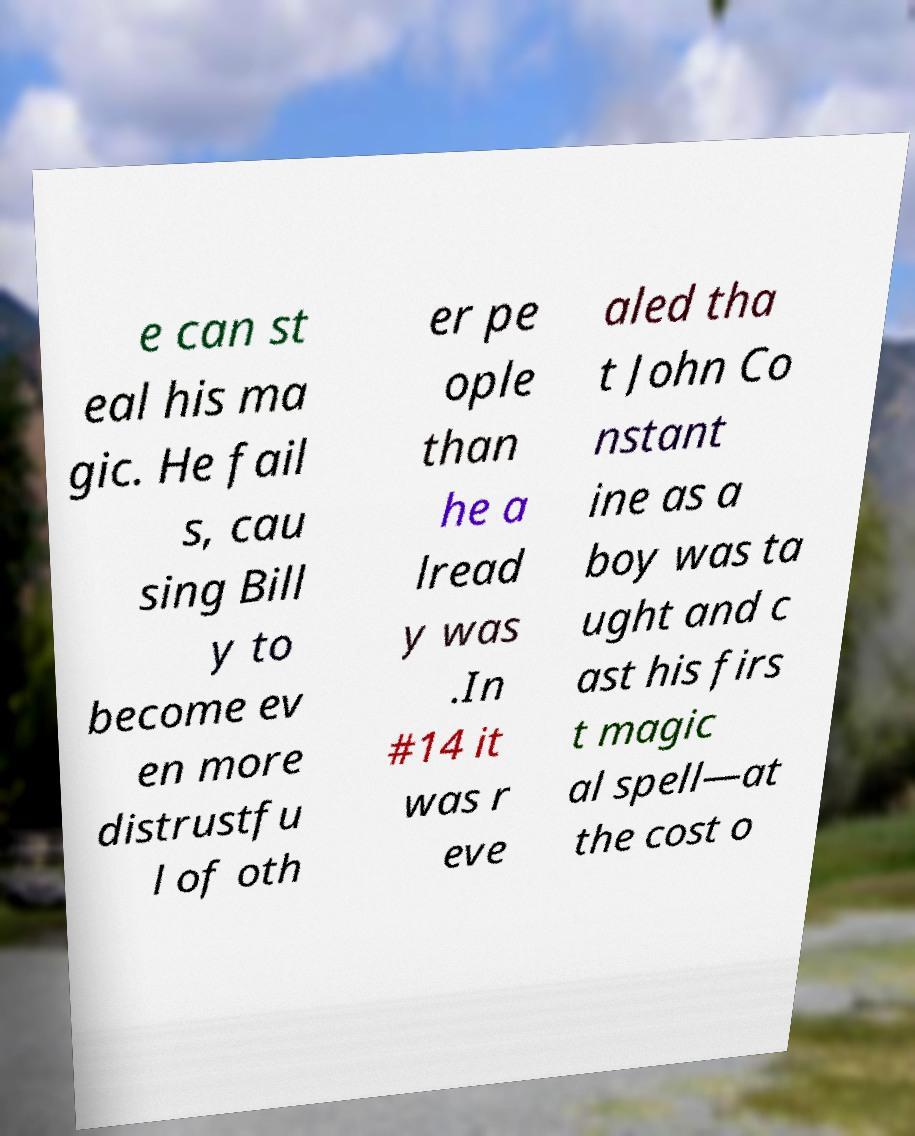For documentation purposes, I need the text within this image transcribed. Could you provide that? e can st eal his ma gic. He fail s, cau sing Bill y to become ev en more distrustfu l of oth er pe ople than he a lread y was .In #14 it was r eve aled tha t John Co nstant ine as a boy was ta ught and c ast his firs t magic al spell—at the cost o 